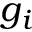Convert formula to latex. <formula><loc_0><loc_0><loc_500><loc_500>g _ { i }</formula> 